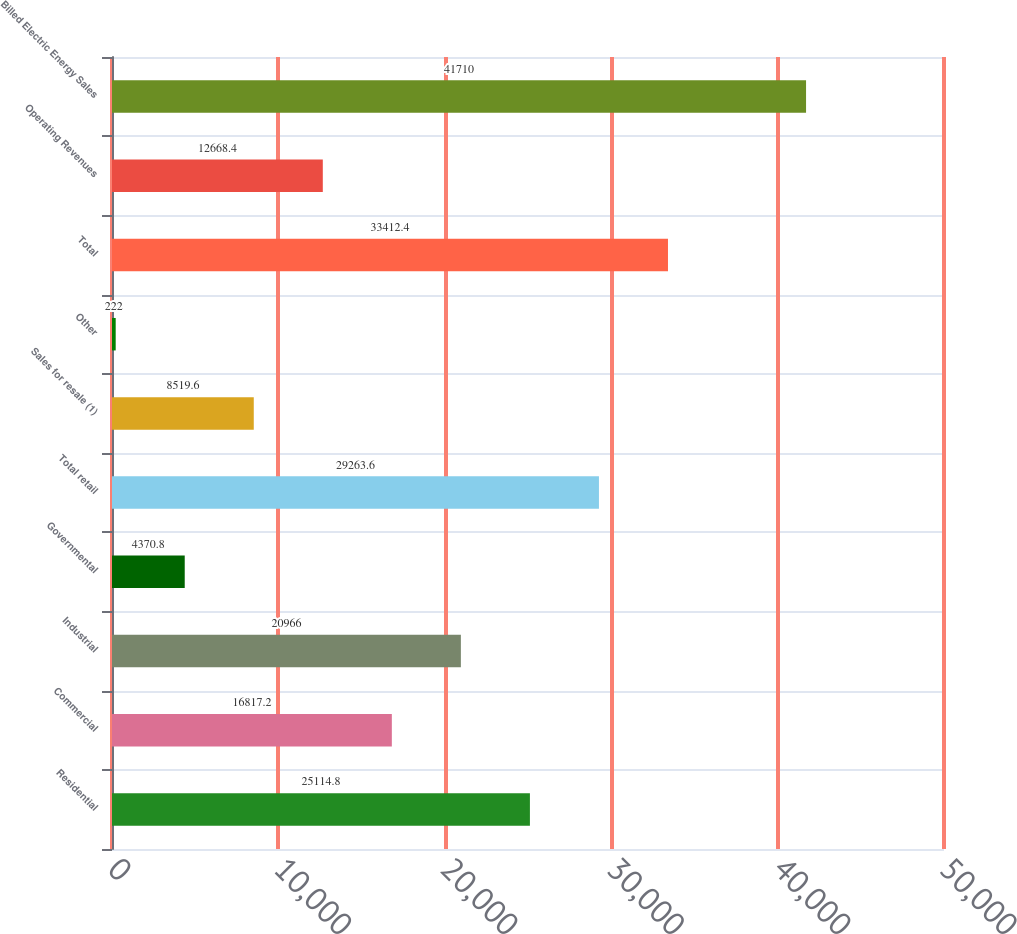Convert chart to OTSL. <chart><loc_0><loc_0><loc_500><loc_500><bar_chart><fcel>Residential<fcel>Commercial<fcel>Industrial<fcel>Governmental<fcel>Total retail<fcel>Sales for resale (1)<fcel>Other<fcel>Total<fcel>Operating Revenues<fcel>Billed Electric Energy Sales<nl><fcel>25114.8<fcel>16817.2<fcel>20966<fcel>4370.8<fcel>29263.6<fcel>8519.6<fcel>222<fcel>33412.4<fcel>12668.4<fcel>41710<nl></chart> 